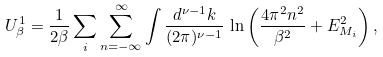Convert formula to latex. <formula><loc_0><loc_0><loc_500><loc_500>U ^ { 1 } _ { \beta } = \frac { 1 } { 2 \beta } \sum _ { i } \sum _ { n = - \infty } ^ { \infty } \int \frac { d ^ { \nu - 1 } k } { ( 2 \pi ) ^ { \nu - 1 } } \, \ln \left ( \frac { 4 \pi ^ { 2 } n ^ { 2 } } { \beta ^ { 2 } } + E _ { M _ { i } } ^ { 2 } \right ) ,</formula> 